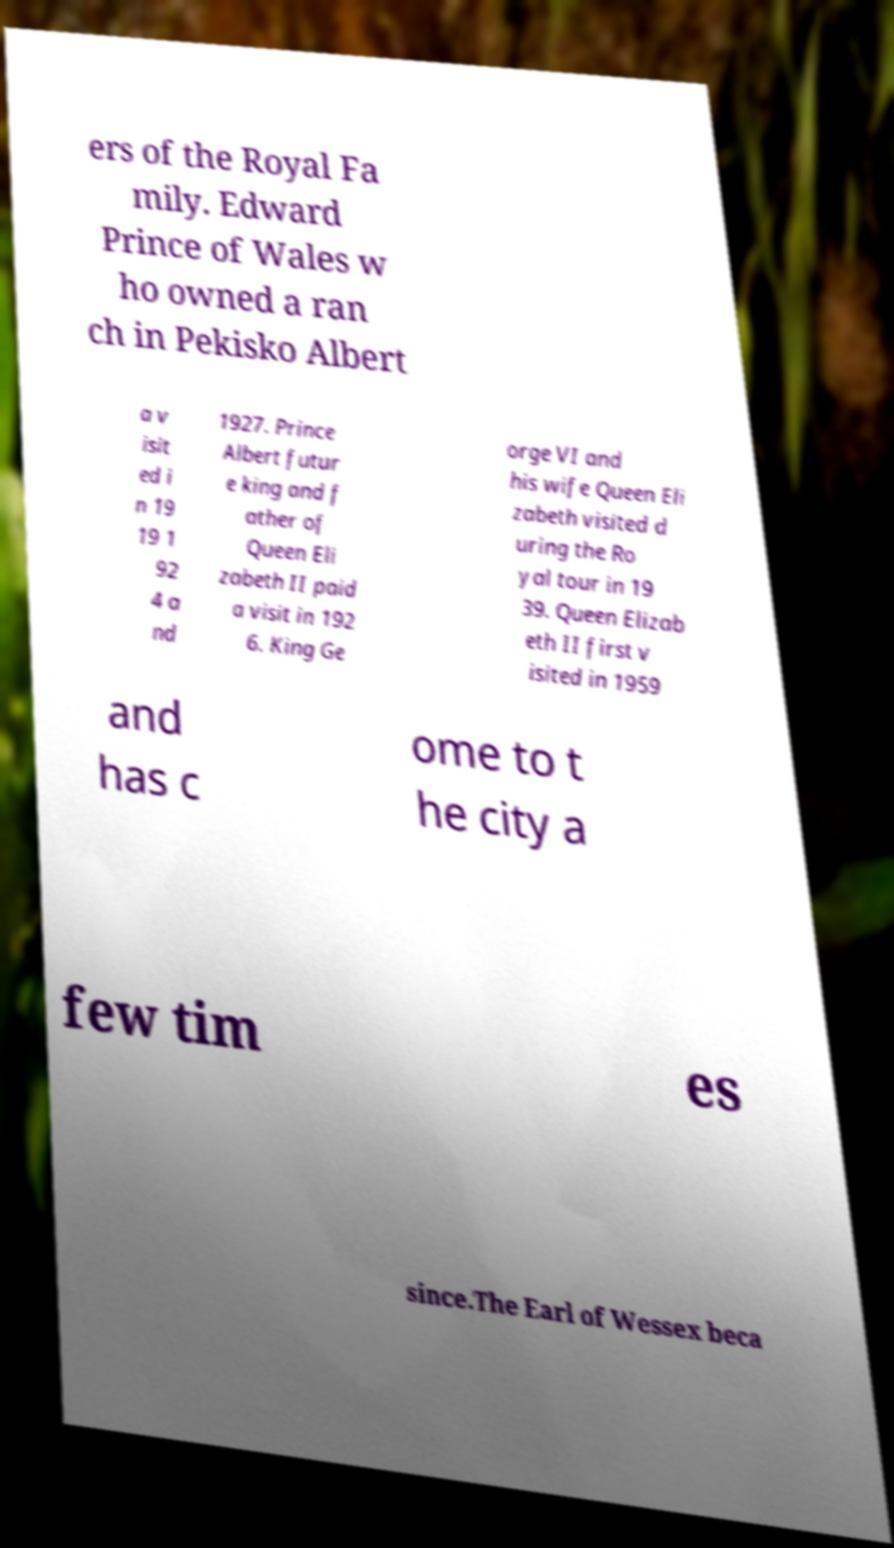There's text embedded in this image that I need extracted. Can you transcribe it verbatim? ers of the Royal Fa mily. Edward Prince of Wales w ho owned a ran ch in Pekisko Albert a v isit ed i n 19 19 1 92 4 a nd 1927. Prince Albert futur e king and f ather of Queen Eli zabeth II paid a visit in 192 6. King Ge orge VI and his wife Queen Eli zabeth visited d uring the Ro yal tour in 19 39. Queen Elizab eth II first v isited in 1959 and has c ome to t he city a few tim es since.The Earl of Wessex beca 